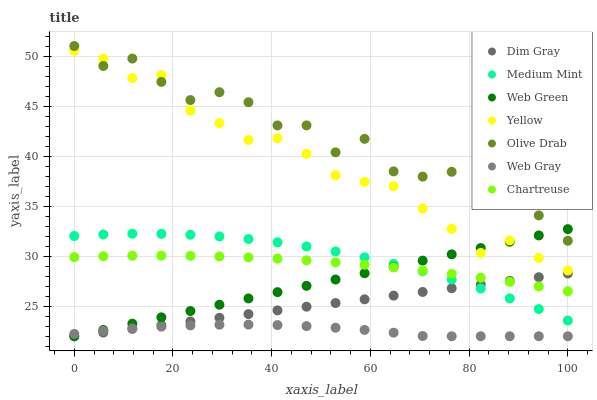Does Web Gray have the minimum area under the curve?
Answer yes or no. Yes. Does Olive Drab have the maximum area under the curve?
Answer yes or no. Yes. Does Dim Gray have the minimum area under the curve?
Answer yes or no. No. Does Dim Gray have the maximum area under the curve?
Answer yes or no. No. Is Web Green the smoothest?
Answer yes or no. Yes. Is Olive Drab the roughest?
Answer yes or no. Yes. Is Dim Gray the smoothest?
Answer yes or no. No. Is Dim Gray the roughest?
Answer yes or no. No. Does Dim Gray have the lowest value?
Answer yes or no. Yes. Does Yellow have the lowest value?
Answer yes or no. No. Does Olive Drab have the highest value?
Answer yes or no. Yes. Does Dim Gray have the highest value?
Answer yes or no. No. Is Web Gray less than Chartreuse?
Answer yes or no. Yes. Is Olive Drab greater than Web Gray?
Answer yes or no. Yes. Does Web Gray intersect Dim Gray?
Answer yes or no. Yes. Is Web Gray less than Dim Gray?
Answer yes or no. No. Is Web Gray greater than Dim Gray?
Answer yes or no. No. Does Web Gray intersect Chartreuse?
Answer yes or no. No. 